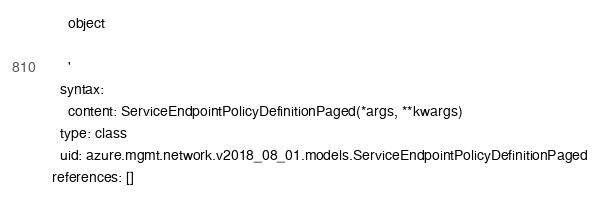<code> <loc_0><loc_0><loc_500><loc_500><_YAML_>    object

    '
  syntax:
    content: ServiceEndpointPolicyDefinitionPaged(*args, **kwargs)
  type: class
  uid: azure.mgmt.network.v2018_08_01.models.ServiceEndpointPolicyDefinitionPaged
references: []
</code> 